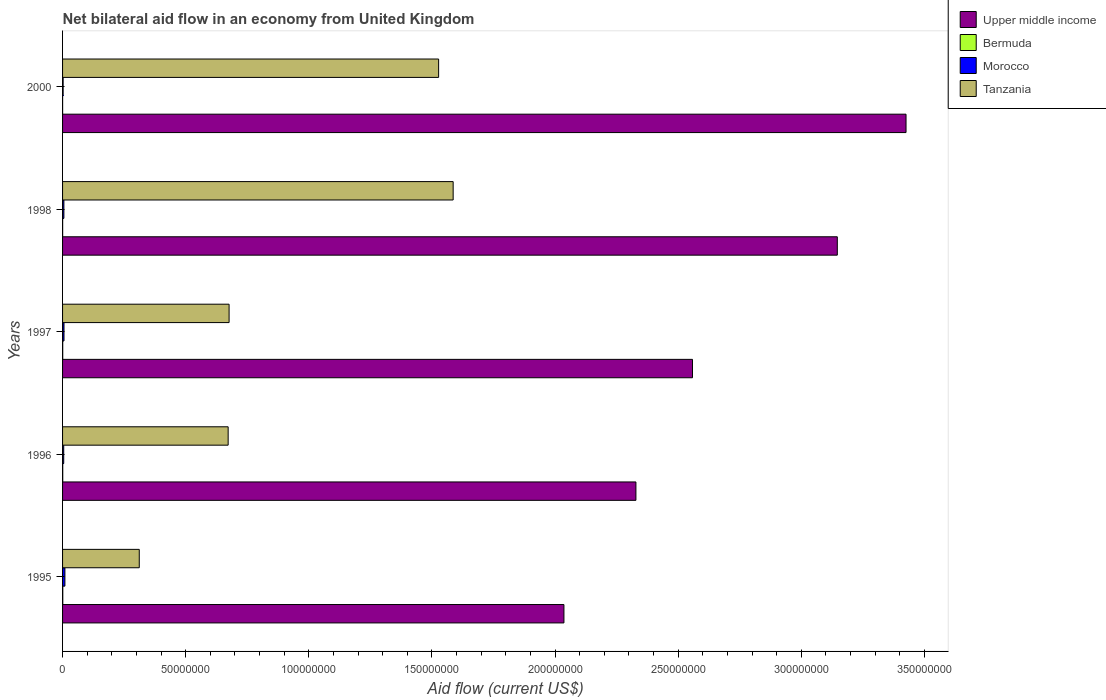How many groups of bars are there?
Your answer should be compact. 5. Are the number of bars per tick equal to the number of legend labels?
Keep it short and to the point. Yes. How many bars are there on the 3rd tick from the top?
Provide a succinct answer. 4. What is the net bilateral aid flow in Tanzania in 1996?
Your answer should be very brief. 6.72e+07. Across all years, what is the maximum net bilateral aid flow in Tanzania?
Provide a succinct answer. 1.59e+08. In which year was the net bilateral aid flow in Tanzania minimum?
Ensure brevity in your answer.  1995. What is the difference between the net bilateral aid flow in Tanzania in 1996 and that in 1998?
Keep it short and to the point. -9.14e+07. What is the difference between the net bilateral aid flow in Upper middle income in 2000 and the net bilateral aid flow in Tanzania in 1998?
Your answer should be compact. 1.84e+08. What is the average net bilateral aid flow in Morocco per year?
Make the answer very short. 5.54e+05. In the year 1997, what is the difference between the net bilateral aid flow in Morocco and net bilateral aid flow in Upper middle income?
Ensure brevity in your answer.  -2.55e+08. What is the ratio of the net bilateral aid flow in Tanzania in 1998 to that in 2000?
Ensure brevity in your answer.  1.04. Is the net bilateral aid flow in Upper middle income in 1995 less than that in 1996?
Offer a very short reply. Yes. What is the difference between the highest and the second highest net bilateral aid flow in Morocco?
Your answer should be compact. 3.70e+05. What is the difference between the highest and the lowest net bilateral aid flow in Tanzania?
Your response must be concise. 1.27e+08. In how many years, is the net bilateral aid flow in Tanzania greater than the average net bilateral aid flow in Tanzania taken over all years?
Your answer should be very brief. 2. Is the sum of the net bilateral aid flow in Upper middle income in 1995 and 1998 greater than the maximum net bilateral aid flow in Bermuda across all years?
Your answer should be compact. Yes. Is it the case that in every year, the sum of the net bilateral aid flow in Morocco and net bilateral aid flow in Bermuda is greater than the sum of net bilateral aid flow in Upper middle income and net bilateral aid flow in Tanzania?
Your answer should be compact. No. What does the 1st bar from the top in 1998 represents?
Make the answer very short. Tanzania. What does the 1st bar from the bottom in 1998 represents?
Ensure brevity in your answer.  Upper middle income. Is it the case that in every year, the sum of the net bilateral aid flow in Upper middle income and net bilateral aid flow in Bermuda is greater than the net bilateral aid flow in Tanzania?
Provide a succinct answer. Yes. Are all the bars in the graph horizontal?
Your answer should be compact. Yes. How many years are there in the graph?
Make the answer very short. 5. What is the difference between two consecutive major ticks on the X-axis?
Keep it short and to the point. 5.00e+07. Does the graph contain any zero values?
Keep it short and to the point. No. Where does the legend appear in the graph?
Your answer should be very brief. Top right. How many legend labels are there?
Offer a terse response. 4. How are the legend labels stacked?
Make the answer very short. Vertical. What is the title of the graph?
Your answer should be very brief. Net bilateral aid flow in an economy from United Kingdom. What is the label or title of the X-axis?
Provide a short and direct response. Aid flow (current US$). What is the Aid flow (current US$) in Upper middle income in 1995?
Make the answer very short. 2.04e+08. What is the Aid flow (current US$) in Bermuda in 1995?
Your answer should be compact. 9.00e+04. What is the Aid flow (current US$) in Morocco in 1995?
Keep it short and to the point. 9.50e+05. What is the Aid flow (current US$) in Tanzania in 1995?
Ensure brevity in your answer.  3.12e+07. What is the Aid flow (current US$) of Upper middle income in 1996?
Ensure brevity in your answer.  2.33e+08. What is the Aid flow (current US$) of Morocco in 1996?
Provide a succinct answer. 4.70e+05. What is the Aid flow (current US$) of Tanzania in 1996?
Your answer should be compact. 6.72e+07. What is the Aid flow (current US$) in Upper middle income in 1997?
Your response must be concise. 2.56e+08. What is the Aid flow (current US$) in Morocco in 1997?
Give a very brief answer. 5.80e+05. What is the Aid flow (current US$) of Tanzania in 1997?
Your response must be concise. 6.76e+07. What is the Aid flow (current US$) in Upper middle income in 1998?
Give a very brief answer. 3.15e+08. What is the Aid flow (current US$) in Morocco in 1998?
Give a very brief answer. 5.40e+05. What is the Aid flow (current US$) of Tanzania in 1998?
Give a very brief answer. 1.59e+08. What is the Aid flow (current US$) of Upper middle income in 2000?
Give a very brief answer. 3.43e+08. What is the Aid flow (current US$) of Tanzania in 2000?
Offer a very short reply. 1.53e+08. Across all years, what is the maximum Aid flow (current US$) in Upper middle income?
Offer a terse response. 3.43e+08. Across all years, what is the maximum Aid flow (current US$) of Morocco?
Provide a short and direct response. 9.50e+05. Across all years, what is the maximum Aid flow (current US$) of Tanzania?
Give a very brief answer. 1.59e+08. Across all years, what is the minimum Aid flow (current US$) in Upper middle income?
Make the answer very short. 2.04e+08. Across all years, what is the minimum Aid flow (current US$) in Tanzania?
Ensure brevity in your answer.  3.12e+07. What is the total Aid flow (current US$) in Upper middle income in the graph?
Your response must be concise. 1.35e+09. What is the total Aid flow (current US$) in Morocco in the graph?
Give a very brief answer. 2.77e+06. What is the total Aid flow (current US$) of Tanzania in the graph?
Offer a terse response. 4.77e+08. What is the difference between the Aid flow (current US$) of Upper middle income in 1995 and that in 1996?
Ensure brevity in your answer.  -2.92e+07. What is the difference between the Aid flow (current US$) of Morocco in 1995 and that in 1996?
Your answer should be very brief. 4.80e+05. What is the difference between the Aid flow (current US$) of Tanzania in 1995 and that in 1996?
Keep it short and to the point. -3.61e+07. What is the difference between the Aid flow (current US$) in Upper middle income in 1995 and that in 1997?
Make the answer very short. -5.22e+07. What is the difference between the Aid flow (current US$) in Morocco in 1995 and that in 1997?
Make the answer very short. 3.70e+05. What is the difference between the Aid flow (current US$) in Tanzania in 1995 and that in 1997?
Provide a short and direct response. -3.65e+07. What is the difference between the Aid flow (current US$) of Upper middle income in 1995 and that in 1998?
Make the answer very short. -1.11e+08. What is the difference between the Aid flow (current US$) of Morocco in 1995 and that in 1998?
Provide a short and direct response. 4.10e+05. What is the difference between the Aid flow (current US$) in Tanzania in 1995 and that in 1998?
Give a very brief answer. -1.27e+08. What is the difference between the Aid flow (current US$) of Upper middle income in 1995 and that in 2000?
Provide a succinct answer. -1.39e+08. What is the difference between the Aid flow (current US$) of Bermuda in 1995 and that in 2000?
Offer a very short reply. 7.00e+04. What is the difference between the Aid flow (current US$) of Morocco in 1995 and that in 2000?
Offer a very short reply. 7.20e+05. What is the difference between the Aid flow (current US$) of Tanzania in 1995 and that in 2000?
Your answer should be very brief. -1.22e+08. What is the difference between the Aid flow (current US$) of Upper middle income in 1996 and that in 1997?
Offer a terse response. -2.30e+07. What is the difference between the Aid flow (current US$) of Morocco in 1996 and that in 1997?
Ensure brevity in your answer.  -1.10e+05. What is the difference between the Aid flow (current US$) in Tanzania in 1996 and that in 1997?
Provide a short and direct response. -3.80e+05. What is the difference between the Aid flow (current US$) in Upper middle income in 1996 and that in 1998?
Offer a very short reply. -8.18e+07. What is the difference between the Aid flow (current US$) of Morocco in 1996 and that in 1998?
Ensure brevity in your answer.  -7.00e+04. What is the difference between the Aid flow (current US$) in Tanzania in 1996 and that in 1998?
Offer a terse response. -9.14e+07. What is the difference between the Aid flow (current US$) of Upper middle income in 1996 and that in 2000?
Ensure brevity in your answer.  -1.10e+08. What is the difference between the Aid flow (current US$) in Tanzania in 1996 and that in 2000?
Provide a succinct answer. -8.55e+07. What is the difference between the Aid flow (current US$) in Upper middle income in 1997 and that in 1998?
Give a very brief answer. -5.88e+07. What is the difference between the Aid flow (current US$) in Bermuda in 1997 and that in 1998?
Ensure brevity in your answer.  3.00e+04. What is the difference between the Aid flow (current US$) in Morocco in 1997 and that in 1998?
Your answer should be very brief. 4.00e+04. What is the difference between the Aid flow (current US$) of Tanzania in 1997 and that in 1998?
Provide a short and direct response. -9.10e+07. What is the difference between the Aid flow (current US$) of Upper middle income in 1997 and that in 2000?
Your answer should be compact. -8.67e+07. What is the difference between the Aid flow (current US$) of Morocco in 1997 and that in 2000?
Provide a succinct answer. 3.50e+05. What is the difference between the Aid flow (current US$) of Tanzania in 1997 and that in 2000?
Your response must be concise. -8.51e+07. What is the difference between the Aid flow (current US$) of Upper middle income in 1998 and that in 2000?
Provide a succinct answer. -2.79e+07. What is the difference between the Aid flow (current US$) of Tanzania in 1998 and that in 2000?
Your response must be concise. 5.90e+06. What is the difference between the Aid flow (current US$) in Upper middle income in 1995 and the Aid flow (current US$) in Bermuda in 1996?
Ensure brevity in your answer.  2.04e+08. What is the difference between the Aid flow (current US$) of Upper middle income in 1995 and the Aid flow (current US$) of Morocco in 1996?
Give a very brief answer. 2.03e+08. What is the difference between the Aid flow (current US$) of Upper middle income in 1995 and the Aid flow (current US$) of Tanzania in 1996?
Offer a very short reply. 1.36e+08. What is the difference between the Aid flow (current US$) in Bermuda in 1995 and the Aid flow (current US$) in Morocco in 1996?
Give a very brief answer. -3.80e+05. What is the difference between the Aid flow (current US$) in Bermuda in 1995 and the Aid flow (current US$) in Tanzania in 1996?
Your answer should be compact. -6.72e+07. What is the difference between the Aid flow (current US$) in Morocco in 1995 and the Aid flow (current US$) in Tanzania in 1996?
Offer a terse response. -6.63e+07. What is the difference between the Aid flow (current US$) of Upper middle income in 1995 and the Aid flow (current US$) of Bermuda in 1997?
Give a very brief answer. 2.04e+08. What is the difference between the Aid flow (current US$) in Upper middle income in 1995 and the Aid flow (current US$) in Morocco in 1997?
Offer a terse response. 2.03e+08. What is the difference between the Aid flow (current US$) in Upper middle income in 1995 and the Aid flow (current US$) in Tanzania in 1997?
Make the answer very short. 1.36e+08. What is the difference between the Aid flow (current US$) of Bermuda in 1995 and the Aid flow (current US$) of Morocco in 1997?
Provide a succinct answer. -4.90e+05. What is the difference between the Aid flow (current US$) of Bermuda in 1995 and the Aid flow (current US$) of Tanzania in 1997?
Make the answer very short. -6.75e+07. What is the difference between the Aid flow (current US$) in Morocco in 1995 and the Aid flow (current US$) in Tanzania in 1997?
Offer a terse response. -6.67e+07. What is the difference between the Aid flow (current US$) in Upper middle income in 1995 and the Aid flow (current US$) in Bermuda in 1998?
Keep it short and to the point. 2.04e+08. What is the difference between the Aid flow (current US$) in Upper middle income in 1995 and the Aid flow (current US$) in Morocco in 1998?
Provide a succinct answer. 2.03e+08. What is the difference between the Aid flow (current US$) of Upper middle income in 1995 and the Aid flow (current US$) of Tanzania in 1998?
Offer a very short reply. 4.50e+07. What is the difference between the Aid flow (current US$) in Bermuda in 1995 and the Aid flow (current US$) in Morocco in 1998?
Give a very brief answer. -4.50e+05. What is the difference between the Aid flow (current US$) of Bermuda in 1995 and the Aid flow (current US$) of Tanzania in 1998?
Provide a short and direct response. -1.59e+08. What is the difference between the Aid flow (current US$) in Morocco in 1995 and the Aid flow (current US$) in Tanzania in 1998?
Your answer should be very brief. -1.58e+08. What is the difference between the Aid flow (current US$) of Upper middle income in 1995 and the Aid flow (current US$) of Bermuda in 2000?
Give a very brief answer. 2.04e+08. What is the difference between the Aid flow (current US$) in Upper middle income in 1995 and the Aid flow (current US$) in Morocco in 2000?
Keep it short and to the point. 2.03e+08. What is the difference between the Aid flow (current US$) in Upper middle income in 1995 and the Aid flow (current US$) in Tanzania in 2000?
Make the answer very short. 5.09e+07. What is the difference between the Aid flow (current US$) of Bermuda in 1995 and the Aid flow (current US$) of Morocco in 2000?
Give a very brief answer. -1.40e+05. What is the difference between the Aid flow (current US$) of Bermuda in 1995 and the Aid flow (current US$) of Tanzania in 2000?
Your answer should be compact. -1.53e+08. What is the difference between the Aid flow (current US$) of Morocco in 1995 and the Aid flow (current US$) of Tanzania in 2000?
Provide a succinct answer. -1.52e+08. What is the difference between the Aid flow (current US$) in Upper middle income in 1996 and the Aid flow (current US$) in Bermuda in 1997?
Give a very brief answer. 2.33e+08. What is the difference between the Aid flow (current US$) in Upper middle income in 1996 and the Aid flow (current US$) in Morocco in 1997?
Provide a short and direct response. 2.32e+08. What is the difference between the Aid flow (current US$) of Upper middle income in 1996 and the Aid flow (current US$) of Tanzania in 1997?
Ensure brevity in your answer.  1.65e+08. What is the difference between the Aid flow (current US$) of Bermuda in 1996 and the Aid flow (current US$) of Morocco in 1997?
Keep it short and to the point. -5.10e+05. What is the difference between the Aid flow (current US$) in Bermuda in 1996 and the Aid flow (current US$) in Tanzania in 1997?
Offer a very short reply. -6.76e+07. What is the difference between the Aid flow (current US$) in Morocco in 1996 and the Aid flow (current US$) in Tanzania in 1997?
Offer a very short reply. -6.72e+07. What is the difference between the Aid flow (current US$) of Upper middle income in 1996 and the Aid flow (current US$) of Bermuda in 1998?
Provide a succinct answer. 2.33e+08. What is the difference between the Aid flow (current US$) of Upper middle income in 1996 and the Aid flow (current US$) of Morocco in 1998?
Provide a short and direct response. 2.32e+08. What is the difference between the Aid flow (current US$) of Upper middle income in 1996 and the Aid flow (current US$) of Tanzania in 1998?
Your response must be concise. 7.42e+07. What is the difference between the Aid flow (current US$) of Bermuda in 1996 and the Aid flow (current US$) of Morocco in 1998?
Provide a succinct answer. -4.70e+05. What is the difference between the Aid flow (current US$) of Bermuda in 1996 and the Aid flow (current US$) of Tanzania in 1998?
Your answer should be compact. -1.59e+08. What is the difference between the Aid flow (current US$) in Morocco in 1996 and the Aid flow (current US$) in Tanzania in 1998?
Your answer should be compact. -1.58e+08. What is the difference between the Aid flow (current US$) in Upper middle income in 1996 and the Aid flow (current US$) in Bermuda in 2000?
Make the answer very short. 2.33e+08. What is the difference between the Aid flow (current US$) of Upper middle income in 1996 and the Aid flow (current US$) of Morocco in 2000?
Offer a very short reply. 2.33e+08. What is the difference between the Aid flow (current US$) in Upper middle income in 1996 and the Aid flow (current US$) in Tanzania in 2000?
Your answer should be compact. 8.01e+07. What is the difference between the Aid flow (current US$) of Bermuda in 1996 and the Aid flow (current US$) of Tanzania in 2000?
Offer a very short reply. -1.53e+08. What is the difference between the Aid flow (current US$) of Morocco in 1996 and the Aid flow (current US$) of Tanzania in 2000?
Provide a short and direct response. -1.52e+08. What is the difference between the Aid flow (current US$) of Upper middle income in 1997 and the Aid flow (current US$) of Bermuda in 1998?
Provide a short and direct response. 2.56e+08. What is the difference between the Aid flow (current US$) in Upper middle income in 1997 and the Aid flow (current US$) in Morocco in 1998?
Offer a terse response. 2.55e+08. What is the difference between the Aid flow (current US$) of Upper middle income in 1997 and the Aid flow (current US$) of Tanzania in 1998?
Provide a succinct answer. 9.72e+07. What is the difference between the Aid flow (current US$) in Bermuda in 1997 and the Aid flow (current US$) in Morocco in 1998?
Your response must be concise. -4.80e+05. What is the difference between the Aid flow (current US$) in Bermuda in 1997 and the Aid flow (current US$) in Tanzania in 1998?
Your response must be concise. -1.59e+08. What is the difference between the Aid flow (current US$) in Morocco in 1997 and the Aid flow (current US$) in Tanzania in 1998?
Your answer should be very brief. -1.58e+08. What is the difference between the Aid flow (current US$) of Upper middle income in 1997 and the Aid flow (current US$) of Bermuda in 2000?
Your answer should be very brief. 2.56e+08. What is the difference between the Aid flow (current US$) of Upper middle income in 1997 and the Aid flow (current US$) of Morocco in 2000?
Keep it short and to the point. 2.56e+08. What is the difference between the Aid flow (current US$) of Upper middle income in 1997 and the Aid flow (current US$) of Tanzania in 2000?
Give a very brief answer. 1.03e+08. What is the difference between the Aid flow (current US$) in Bermuda in 1997 and the Aid flow (current US$) in Morocco in 2000?
Offer a terse response. -1.70e+05. What is the difference between the Aid flow (current US$) of Bermuda in 1997 and the Aid flow (current US$) of Tanzania in 2000?
Keep it short and to the point. -1.53e+08. What is the difference between the Aid flow (current US$) of Morocco in 1997 and the Aid flow (current US$) of Tanzania in 2000?
Ensure brevity in your answer.  -1.52e+08. What is the difference between the Aid flow (current US$) in Upper middle income in 1998 and the Aid flow (current US$) in Bermuda in 2000?
Your answer should be very brief. 3.15e+08. What is the difference between the Aid flow (current US$) in Upper middle income in 1998 and the Aid flow (current US$) in Morocco in 2000?
Give a very brief answer. 3.14e+08. What is the difference between the Aid flow (current US$) in Upper middle income in 1998 and the Aid flow (current US$) in Tanzania in 2000?
Provide a succinct answer. 1.62e+08. What is the difference between the Aid flow (current US$) of Bermuda in 1998 and the Aid flow (current US$) of Morocco in 2000?
Your answer should be very brief. -2.00e+05. What is the difference between the Aid flow (current US$) in Bermuda in 1998 and the Aid flow (current US$) in Tanzania in 2000?
Provide a short and direct response. -1.53e+08. What is the difference between the Aid flow (current US$) of Morocco in 1998 and the Aid flow (current US$) of Tanzania in 2000?
Offer a very short reply. -1.52e+08. What is the average Aid flow (current US$) of Upper middle income per year?
Your response must be concise. 2.70e+08. What is the average Aid flow (current US$) in Bermuda per year?
Offer a terse response. 5.40e+04. What is the average Aid flow (current US$) in Morocco per year?
Ensure brevity in your answer.  5.54e+05. What is the average Aid flow (current US$) in Tanzania per year?
Provide a short and direct response. 9.55e+07. In the year 1995, what is the difference between the Aid flow (current US$) of Upper middle income and Aid flow (current US$) of Bermuda?
Provide a succinct answer. 2.04e+08. In the year 1995, what is the difference between the Aid flow (current US$) in Upper middle income and Aid flow (current US$) in Morocco?
Give a very brief answer. 2.03e+08. In the year 1995, what is the difference between the Aid flow (current US$) in Upper middle income and Aid flow (current US$) in Tanzania?
Provide a succinct answer. 1.72e+08. In the year 1995, what is the difference between the Aid flow (current US$) in Bermuda and Aid flow (current US$) in Morocco?
Provide a succinct answer. -8.60e+05. In the year 1995, what is the difference between the Aid flow (current US$) in Bermuda and Aid flow (current US$) in Tanzania?
Ensure brevity in your answer.  -3.11e+07. In the year 1995, what is the difference between the Aid flow (current US$) in Morocco and Aid flow (current US$) in Tanzania?
Offer a very short reply. -3.02e+07. In the year 1996, what is the difference between the Aid flow (current US$) of Upper middle income and Aid flow (current US$) of Bermuda?
Ensure brevity in your answer.  2.33e+08. In the year 1996, what is the difference between the Aid flow (current US$) of Upper middle income and Aid flow (current US$) of Morocco?
Your response must be concise. 2.32e+08. In the year 1996, what is the difference between the Aid flow (current US$) in Upper middle income and Aid flow (current US$) in Tanzania?
Offer a terse response. 1.66e+08. In the year 1996, what is the difference between the Aid flow (current US$) of Bermuda and Aid flow (current US$) of Morocco?
Offer a terse response. -4.00e+05. In the year 1996, what is the difference between the Aid flow (current US$) of Bermuda and Aid flow (current US$) of Tanzania?
Your answer should be compact. -6.72e+07. In the year 1996, what is the difference between the Aid flow (current US$) of Morocco and Aid flow (current US$) of Tanzania?
Keep it short and to the point. -6.68e+07. In the year 1997, what is the difference between the Aid flow (current US$) of Upper middle income and Aid flow (current US$) of Bermuda?
Make the answer very short. 2.56e+08. In the year 1997, what is the difference between the Aid flow (current US$) in Upper middle income and Aid flow (current US$) in Morocco?
Your answer should be compact. 2.55e+08. In the year 1997, what is the difference between the Aid flow (current US$) in Upper middle income and Aid flow (current US$) in Tanzania?
Ensure brevity in your answer.  1.88e+08. In the year 1997, what is the difference between the Aid flow (current US$) in Bermuda and Aid flow (current US$) in Morocco?
Your answer should be very brief. -5.20e+05. In the year 1997, what is the difference between the Aid flow (current US$) in Bermuda and Aid flow (current US$) in Tanzania?
Your answer should be compact. -6.76e+07. In the year 1997, what is the difference between the Aid flow (current US$) in Morocco and Aid flow (current US$) in Tanzania?
Give a very brief answer. -6.70e+07. In the year 1998, what is the difference between the Aid flow (current US$) in Upper middle income and Aid flow (current US$) in Bermuda?
Your response must be concise. 3.15e+08. In the year 1998, what is the difference between the Aid flow (current US$) in Upper middle income and Aid flow (current US$) in Morocco?
Your answer should be compact. 3.14e+08. In the year 1998, what is the difference between the Aid flow (current US$) in Upper middle income and Aid flow (current US$) in Tanzania?
Provide a succinct answer. 1.56e+08. In the year 1998, what is the difference between the Aid flow (current US$) in Bermuda and Aid flow (current US$) in Morocco?
Keep it short and to the point. -5.10e+05. In the year 1998, what is the difference between the Aid flow (current US$) of Bermuda and Aid flow (current US$) of Tanzania?
Provide a short and direct response. -1.59e+08. In the year 1998, what is the difference between the Aid flow (current US$) of Morocco and Aid flow (current US$) of Tanzania?
Offer a very short reply. -1.58e+08. In the year 2000, what is the difference between the Aid flow (current US$) of Upper middle income and Aid flow (current US$) of Bermuda?
Your answer should be compact. 3.43e+08. In the year 2000, what is the difference between the Aid flow (current US$) of Upper middle income and Aid flow (current US$) of Morocco?
Offer a very short reply. 3.42e+08. In the year 2000, what is the difference between the Aid flow (current US$) in Upper middle income and Aid flow (current US$) in Tanzania?
Provide a succinct answer. 1.90e+08. In the year 2000, what is the difference between the Aid flow (current US$) of Bermuda and Aid flow (current US$) of Morocco?
Keep it short and to the point. -2.10e+05. In the year 2000, what is the difference between the Aid flow (current US$) in Bermuda and Aid flow (current US$) in Tanzania?
Provide a short and direct response. -1.53e+08. In the year 2000, what is the difference between the Aid flow (current US$) in Morocco and Aid flow (current US$) in Tanzania?
Your response must be concise. -1.52e+08. What is the ratio of the Aid flow (current US$) of Upper middle income in 1995 to that in 1996?
Offer a very short reply. 0.87. What is the ratio of the Aid flow (current US$) in Morocco in 1995 to that in 1996?
Offer a terse response. 2.02. What is the ratio of the Aid flow (current US$) of Tanzania in 1995 to that in 1996?
Provide a short and direct response. 0.46. What is the ratio of the Aid flow (current US$) in Upper middle income in 1995 to that in 1997?
Give a very brief answer. 0.8. What is the ratio of the Aid flow (current US$) of Bermuda in 1995 to that in 1997?
Keep it short and to the point. 1.5. What is the ratio of the Aid flow (current US$) in Morocco in 1995 to that in 1997?
Keep it short and to the point. 1.64. What is the ratio of the Aid flow (current US$) of Tanzania in 1995 to that in 1997?
Your answer should be compact. 0.46. What is the ratio of the Aid flow (current US$) in Upper middle income in 1995 to that in 1998?
Offer a very short reply. 0.65. What is the ratio of the Aid flow (current US$) in Bermuda in 1995 to that in 1998?
Your response must be concise. 3. What is the ratio of the Aid flow (current US$) of Morocco in 1995 to that in 1998?
Keep it short and to the point. 1.76. What is the ratio of the Aid flow (current US$) in Tanzania in 1995 to that in 1998?
Your answer should be compact. 0.2. What is the ratio of the Aid flow (current US$) in Upper middle income in 1995 to that in 2000?
Offer a very short reply. 0.59. What is the ratio of the Aid flow (current US$) of Bermuda in 1995 to that in 2000?
Ensure brevity in your answer.  4.5. What is the ratio of the Aid flow (current US$) of Morocco in 1995 to that in 2000?
Keep it short and to the point. 4.13. What is the ratio of the Aid flow (current US$) of Tanzania in 1995 to that in 2000?
Provide a succinct answer. 0.2. What is the ratio of the Aid flow (current US$) in Upper middle income in 1996 to that in 1997?
Provide a succinct answer. 0.91. What is the ratio of the Aid flow (current US$) in Morocco in 1996 to that in 1997?
Provide a succinct answer. 0.81. What is the ratio of the Aid flow (current US$) in Upper middle income in 1996 to that in 1998?
Offer a very short reply. 0.74. What is the ratio of the Aid flow (current US$) in Bermuda in 1996 to that in 1998?
Offer a very short reply. 2.33. What is the ratio of the Aid flow (current US$) of Morocco in 1996 to that in 1998?
Offer a terse response. 0.87. What is the ratio of the Aid flow (current US$) in Tanzania in 1996 to that in 1998?
Provide a short and direct response. 0.42. What is the ratio of the Aid flow (current US$) of Upper middle income in 1996 to that in 2000?
Your answer should be very brief. 0.68. What is the ratio of the Aid flow (current US$) of Bermuda in 1996 to that in 2000?
Your answer should be compact. 3.5. What is the ratio of the Aid flow (current US$) in Morocco in 1996 to that in 2000?
Give a very brief answer. 2.04. What is the ratio of the Aid flow (current US$) of Tanzania in 1996 to that in 2000?
Your response must be concise. 0.44. What is the ratio of the Aid flow (current US$) of Upper middle income in 1997 to that in 1998?
Your answer should be very brief. 0.81. What is the ratio of the Aid flow (current US$) of Morocco in 1997 to that in 1998?
Provide a succinct answer. 1.07. What is the ratio of the Aid flow (current US$) in Tanzania in 1997 to that in 1998?
Offer a terse response. 0.43. What is the ratio of the Aid flow (current US$) of Upper middle income in 1997 to that in 2000?
Your response must be concise. 0.75. What is the ratio of the Aid flow (current US$) of Bermuda in 1997 to that in 2000?
Offer a very short reply. 3. What is the ratio of the Aid flow (current US$) of Morocco in 1997 to that in 2000?
Provide a short and direct response. 2.52. What is the ratio of the Aid flow (current US$) of Tanzania in 1997 to that in 2000?
Your answer should be very brief. 0.44. What is the ratio of the Aid flow (current US$) in Upper middle income in 1998 to that in 2000?
Provide a short and direct response. 0.92. What is the ratio of the Aid flow (current US$) of Morocco in 1998 to that in 2000?
Provide a short and direct response. 2.35. What is the ratio of the Aid flow (current US$) in Tanzania in 1998 to that in 2000?
Keep it short and to the point. 1.04. What is the difference between the highest and the second highest Aid flow (current US$) of Upper middle income?
Give a very brief answer. 2.79e+07. What is the difference between the highest and the second highest Aid flow (current US$) of Morocco?
Make the answer very short. 3.70e+05. What is the difference between the highest and the second highest Aid flow (current US$) of Tanzania?
Your answer should be compact. 5.90e+06. What is the difference between the highest and the lowest Aid flow (current US$) of Upper middle income?
Give a very brief answer. 1.39e+08. What is the difference between the highest and the lowest Aid flow (current US$) in Morocco?
Make the answer very short. 7.20e+05. What is the difference between the highest and the lowest Aid flow (current US$) of Tanzania?
Your answer should be very brief. 1.27e+08. 